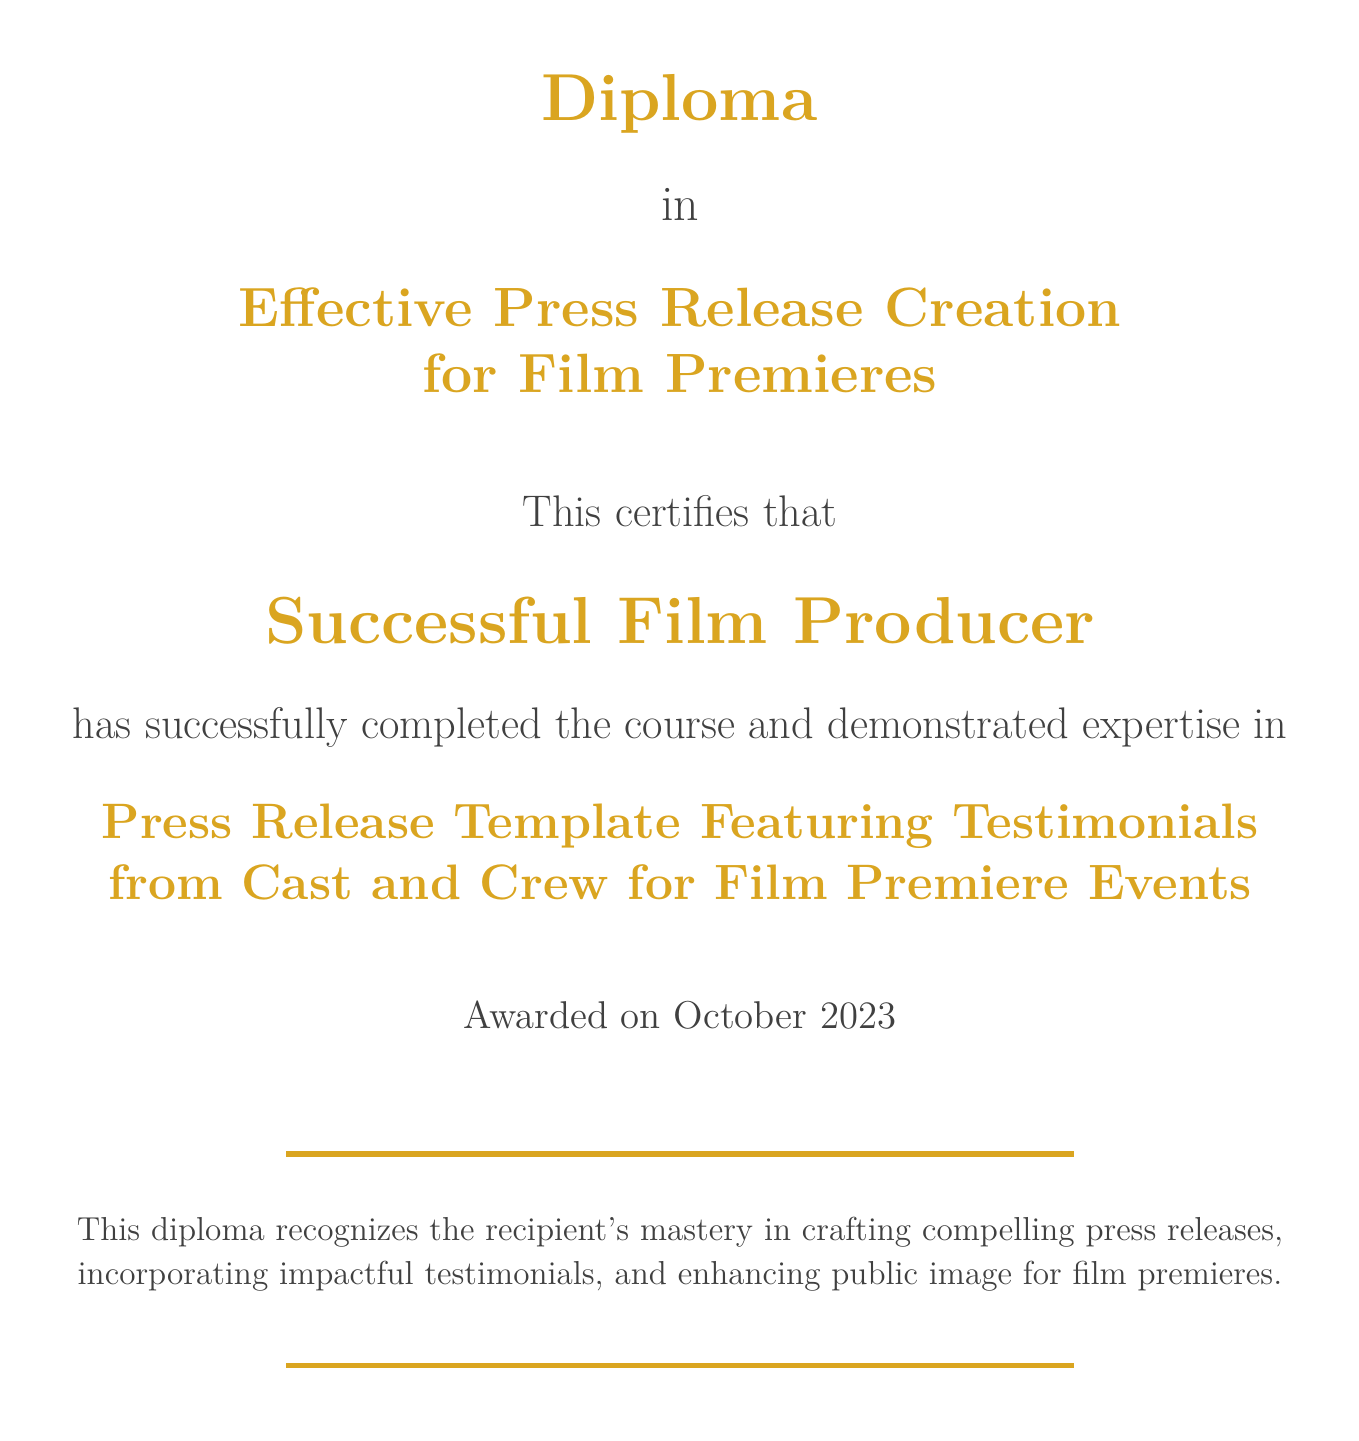What is the document title? The title of the document is prominently displayed at the top, indicating the purpose of the diploma.
Answer: Effective Press Release Creation for Film Premieres Who is the recipient of the diploma? The recipient's name is clearly stated in the middle section of the document, highlighting their achievement.
Answer: Successful Film Producer What is the focus of the diploma? The main focus of the diploma is indicated by a specific phrase included in the document.
Answer: Press Release Template Featuring Testimonials When was the diploma awarded? The date of awarding is mentioned towards the end of the document, signifying completion.
Answer: October 2023 What is the color used for the diploma title? The document features a specific color for the title, which can be found in the color scheme description.
Answer: Gold What does this diploma recognize? The recognition stated in the document includes specific skills and expertise achieved by the recipient.
Answer: Mastery in crafting compelling press releases What is the color used in the decorative lines? The decorative lines in the document utilize a specific color, which is listed in the document's coding.
Answer: Gold accent What type of press releases does the diploma specify? The diploma details a specific type of press release that is highlighted within its text.
Answer: Featuring Testimonials from Cast and Crew What is the purpose of the diploma according to the document? The purpose is briefly defined in a summary statement related to the recipient’s skills.
Answer: Enhancing public image for film premieres 